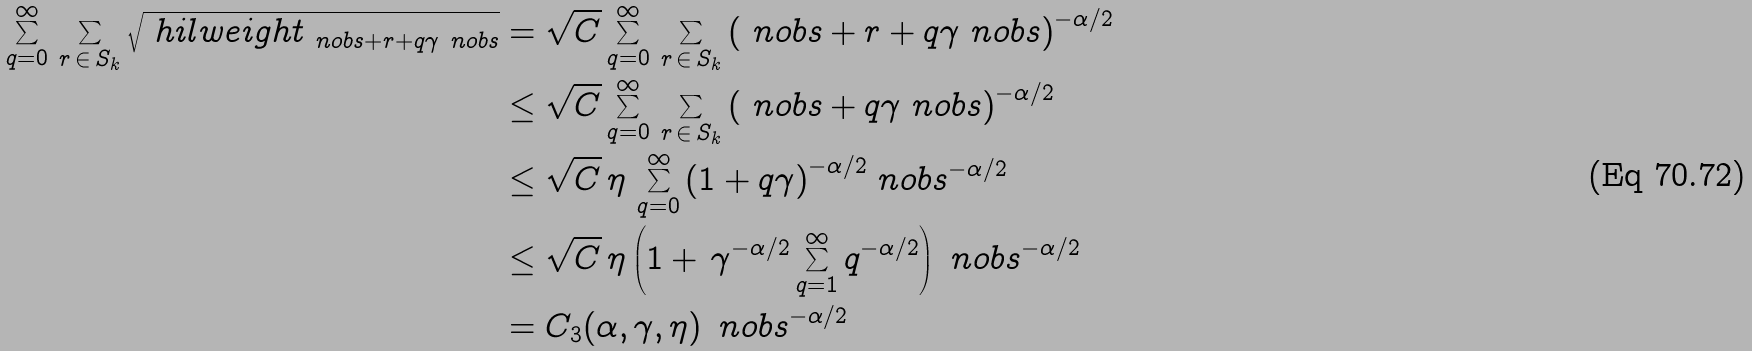Convert formula to latex. <formula><loc_0><loc_0><loc_500><loc_500>\sum _ { q = 0 } ^ { \infty } \, \sum _ { r \, \in \, S _ { k } } \sqrt { \ h i l w e i g h t _ { \ n o b s + r + q \gamma \ n o b s } } & = \sqrt { C } \sum _ { q = 0 } ^ { \infty } \, \sum _ { r \, \in \, S _ { k } } { ( \ n o b s + r + q \gamma \ n o b s ) } ^ { - \alpha / 2 } \\ & \leq \sqrt { C } \sum _ { q = 0 } ^ { \infty } \, \sum _ { r \, \in \, S _ { k } } { ( \ n o b s + q \gamma \ n o b s ) } ^ { - \alpha / 2 } \\ & \leq \sqrt { C } \, \eta \, \sum _ { q = 0 } ^ { \infty } { ( 1 + q \gamma ) } ^ { - \alpha / 2 } \ n o b s ^ { - \alpha / 2 } \\ & \leq \sqrt { C } \, \eta \left ( 1 + \, \gamma ^ { - \alpha / 2 } \sum _ { q = 1 } ^ { \infty } q ^ { - \alpha / 2 } \right ) \ n o b s ^ { - \alpha / 2 } \\ & = C _ { 3 } ( \alpha , \gamma , \eta ) \, \ n o b s ^ { - \alpha / 2 }</formula> 